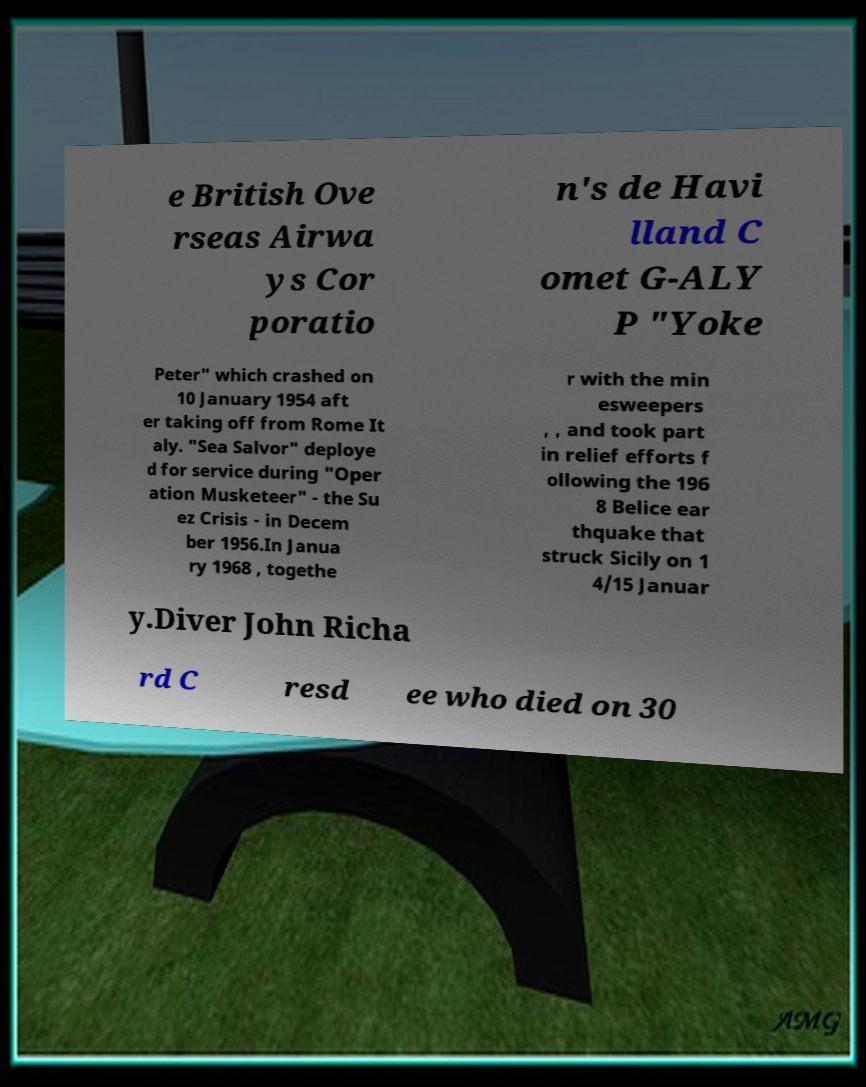There's text embedded in this image that I need extracted. Can you transcribe it verbatim? e British Ove rseas Airwa ys Cor poratio n's de Havi lland C omet G-ALY P "Yoke Peter" which crashed on 10 January 1954 aft er taking off from Rome It aly. "Sea Salvor" deploye d for service during "Oper ation Musketeer" - the Su ez Crisis - in Decem ber 1956.In Janua ry 1968 , togethe r with the min esweepers , , and took part in relief efforts f ollowing the 196 8 Belice ear thquake that struck Sicily on 1 4/15 Januar y.Diver John Richa rd C resd ee who died on 30 